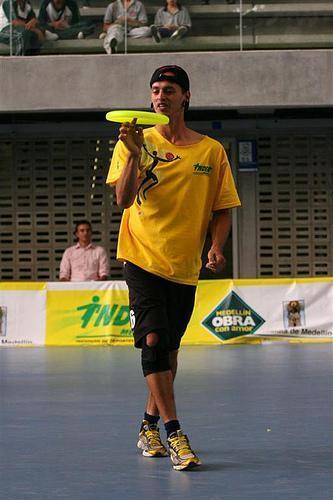How many disks?
Give a very brief answer. 1. 